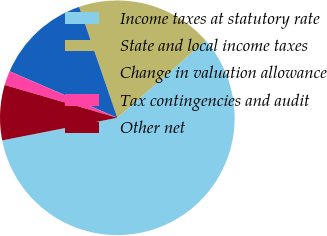Convert chart to OTSL. <chart><loc_0><loc_0><loc_500><loc_500><pie_chart><fcel>Income taxes at statutory rate<fcel>State and local income taxes<fcel>Change in valuation allowance<fcel>Tax contingencies and audit<fcel>Other net<nl><fcel>58.32%<fcel>18.87%<fcel>13.24%<fcel>1.97%<fcel>7.6%<nl></chart> 